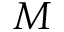Convert formula to latex. <formula><loc_0><loc_0><loc_500><loc_500>M</formula> 